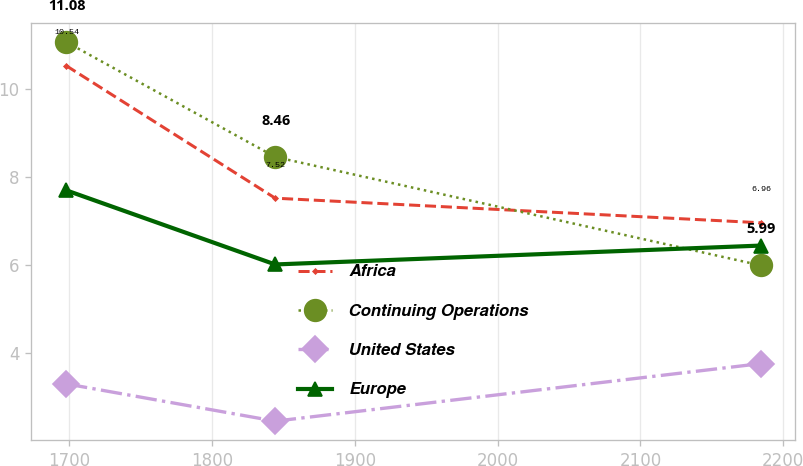Convert chart. <chart><loc_0><loc_0><loc_500><loc_500><line_chart><ecel><fcel>Africa<fcel>Continuing Operations<fcel>United States<fcel>Europe<nl><fcel>1697.93<fcel>10.54<fcel>11.08<fcel>3.29<fcel>7.7<nl><fcel>1844.31<fcel>7.52<fcel>8.46<fcel>2.44<fcel>6.01<nl><fcel>2184.11<fcel>6.96<fcel>5.99<fcel>3.75<fcel>6.44<nl></chart> 